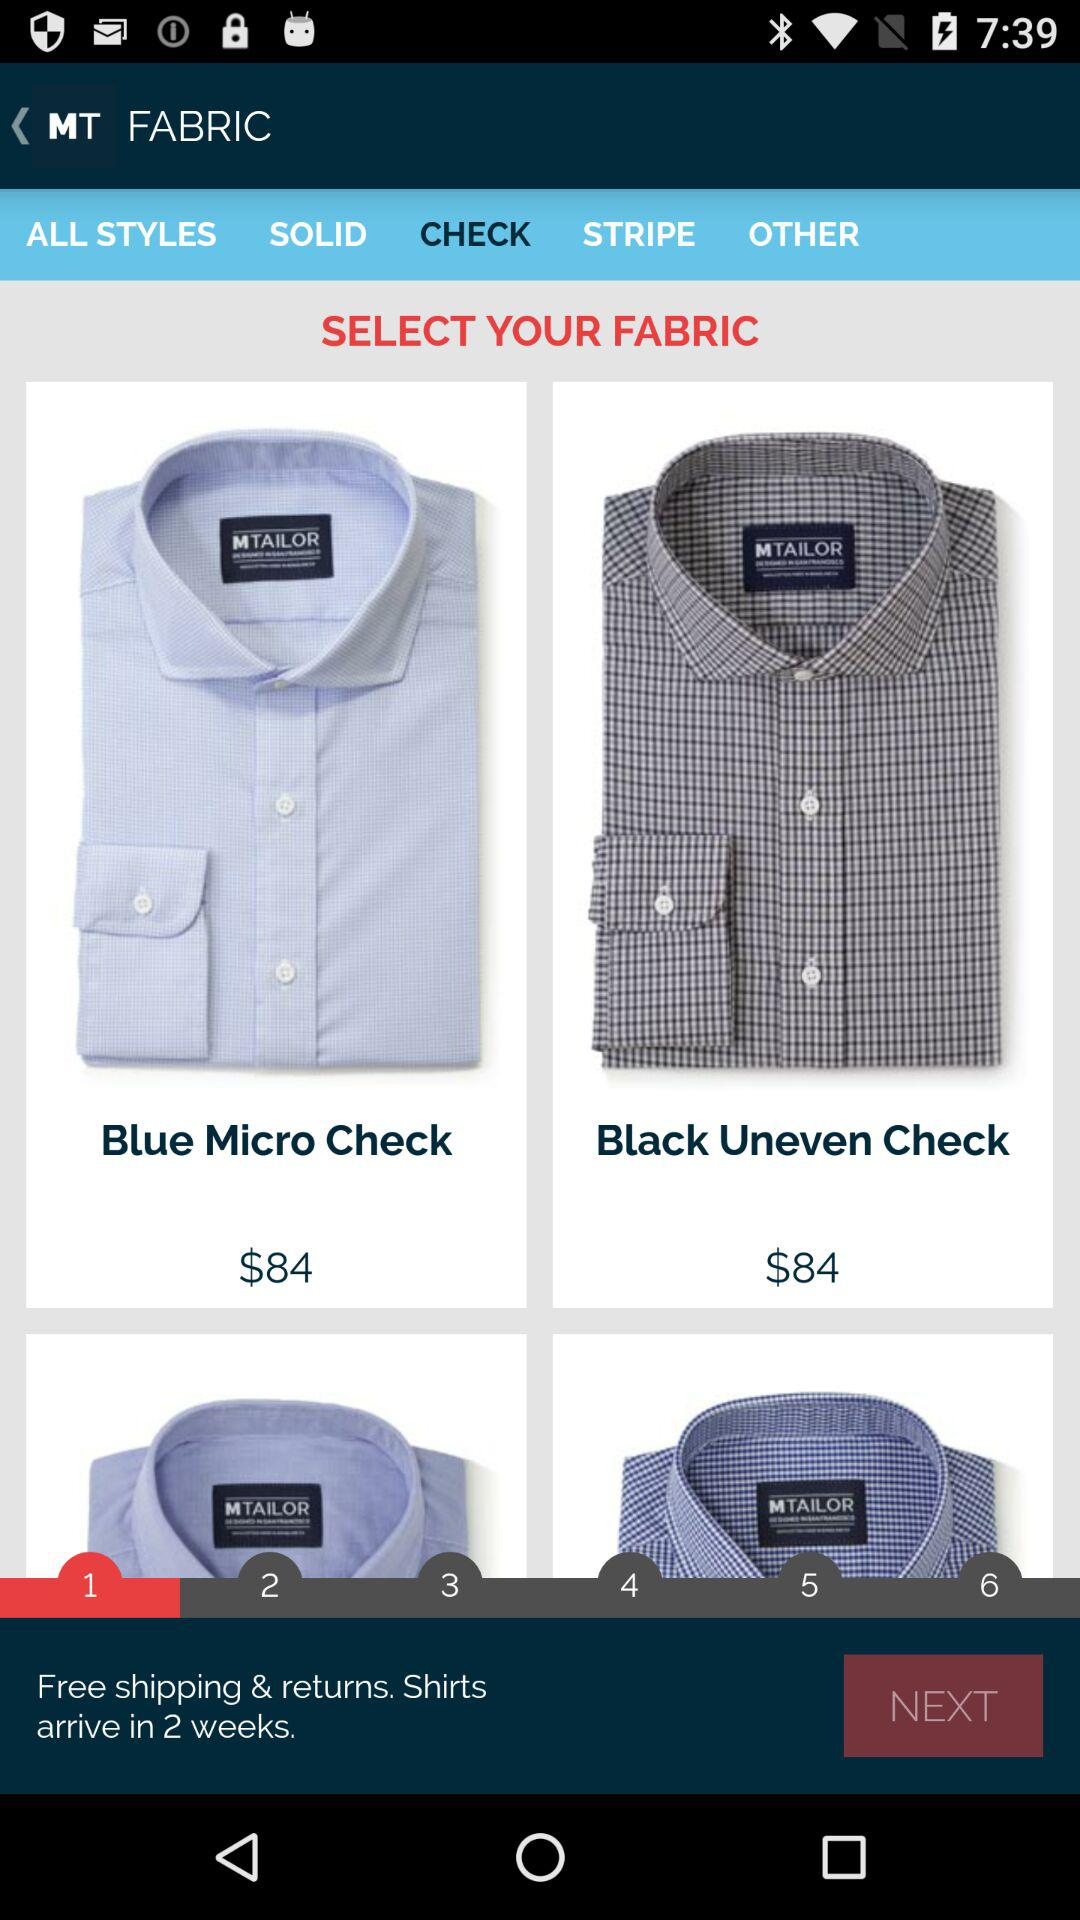What is the price of "Blue Micro Check"? The price of "Blue Micro Check" is $84. 